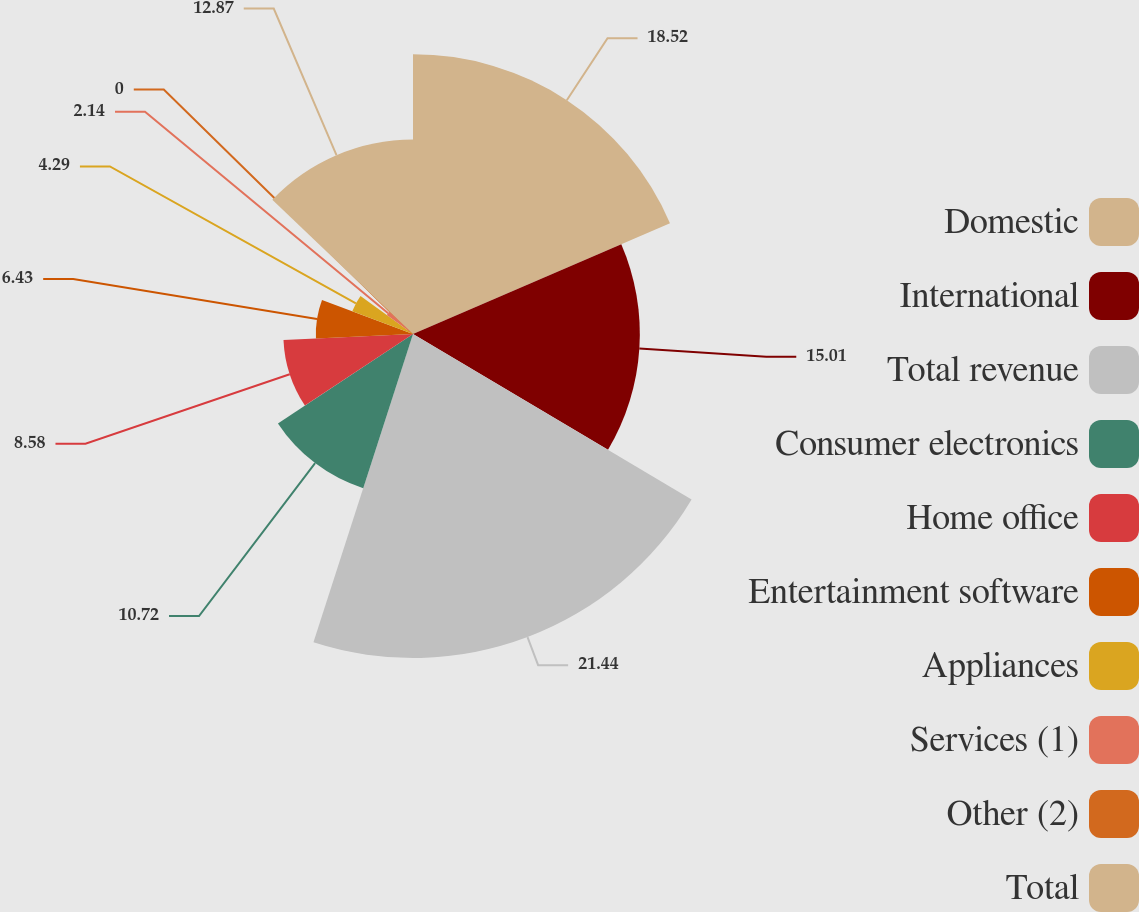<chart> <loc_0><loc_0><loc_500><loc_500><pie_chart><fcel>Domestic<fcel>International<fcel>Total revenue<fcel>Consumer electronics<fcel>Home office<fcel>Entertainment software<fcel>Appliances<fcel>Services (1)<fcel>Other (2)<fcel>Total<nl><fcel>18.52%<fcel>15.01%<fcel>21.44%<fcel>10.72%<fcel>8.58%<fcel>6.43%<fcel>4.29%<fcel>2.14%<fcel>0.0%<fcel>12.87%<nl></chart> 